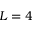Convert formula to latex. <formula><loc_0><loc_0><loc_500><loc_500>L = 4</formula> 